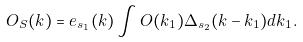Convert formula to latex. <formula><loc_0><loc_0><loc_500><loc_500>O _ { S } ( k ) = e _ { s _ { 1 } } ( k ) \int O ( k _ { 1 } ) \Delta _ { s _ { 2 } } ( k - k _ { 1 } ) d k _ { 1 } .</formula> 